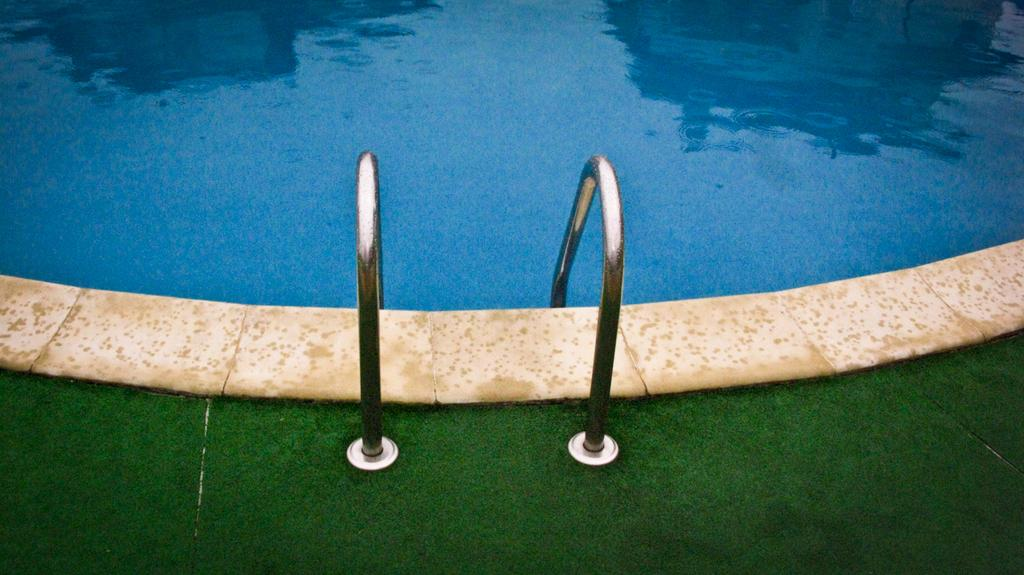What is the main feature of the image? There is a swimming pool in the image. Are there any structures or objects related to the swimming pool? Yes, there are two railings in the image. What type of surface is visible in the image? There is a grass mat in the image. What type of club does the aunt use to catch fish in the image? There is no club, aunt, or fishing activity depicted in the image. 